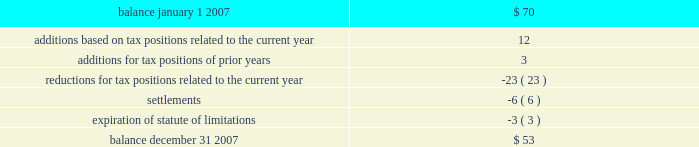Notes to consolidated financial statements note 11 .
Income taxes 2013 ( continued ) the federal income tax return for 2006 is subject to examination by the irs .
In addition for 2007 and 2008 , the irs has invited the company to participate in the compliance assurance process ( 201ccap 201d ) , which is a voluntary program for a limited number of large corporations .
Under cap , the irs conducts a real-time audit and works contemporaneously with the company to resolve any issues prior to the filing of the tax return .
The company has agreed to participate .
The company believes this approach should reduce tax-related uncertainties , if any .
The company and/or its subsidiaries also file income tax returns in various state , local and foreign jurisdictions .
These returns , with few exceptions , are no longer subject to examination by the various taxing authorities before as discussed in note 1 , the company adopted the provisions of fin no .
48 , 201caccounting for uncertainty in income taxes , 201d on january 1 , 2007 .
As a result of the implementation of fin no .
48 , the company recognized a decrease to beginning retained earnings on january 1 , 2007 of $ 37 million .
The total amount of unrecognized tax benefits as of the date of adoption was approximately $ 70 million .
Included in the balance at january 1 , 2007 , were $ 51 million of tax positions that if recognized would affect the effective tax rate .
A reconciliation of the beginning and ending amount of unrecognized tax benefits is as follows : ( in millions ) .
The company anticipates that it is reasonably possible that payments of approximately $ 2 million will be made primarily due to the conclusion of state income tax examinations within the next 12 months .
Additionally , certain state and foreign income tax returns will no longer be subject to examination and as a result , there is a reasonable possibility that the amount of unrecognized tax benefits will decrease by $ 7 million .
At december 31 , 2007 , there were $ 42 million of tax benefits that if recognized would affect the effective rate .
The company recognizes interest accrued related to : ( 1 ) unrecognized tax benefits in interest expense and ( 2 ) tax refund claims in other revenues on the consolidated statements of income .
The company recognizes penalties in income tax expense ( benefit ) on the consolidated statements of income .
During 2007 , the company recorded charges of approximately $ 4 million for interest expense and $ 2 million for penalties .
Provision has been made for the expected u.s .
Federal income tax liabilities applicable to undistributed earnings of subsidiaries , except for certain subsidiaries for which the company intends to invest the undistributed earnings indefinitely , or recover such undistributed earnings tax-free .
At december 31 , 2007 , the company has not provided deferred taxes of $ 126 million , if sold through a taxable sale , on $ 361 million of undistributed earnings related to a domestic affiliate .
The determination of the amount of the unrecognized deferred tax liability related to the undistributed earnings of foreign subsidiaries is not practicable .
In connection with a non-recurring distribution of $ 850 million to diamond offshore from a foreign subsidiary , a portion of which consisted of earnings of the subsidiary that had not previously been subjected to u.s .
Federal income tax , diamond offshore recognized $ 59 million of u.s .
Federal income tax expense as a result of the distribution .
It remains diamond offshore 2019s intention to indefinitely reinvest future earnings of the subsidiary to finance foreign activities .
Total income tax expense for the years ended december 31 , 2007 , 2006 and 2005 , was different than the amounts of $ 1601 million , $ 1557 million and $ 639 million , computed by applying the statutory u.s .
Federal income tax rate of 35% ( 35 % ) to income before income taxes and minority interest for each of the years. .
What is the income before tax in 2006? 
Computations: (1557 / 35%)
Answer: 4448.57143. 